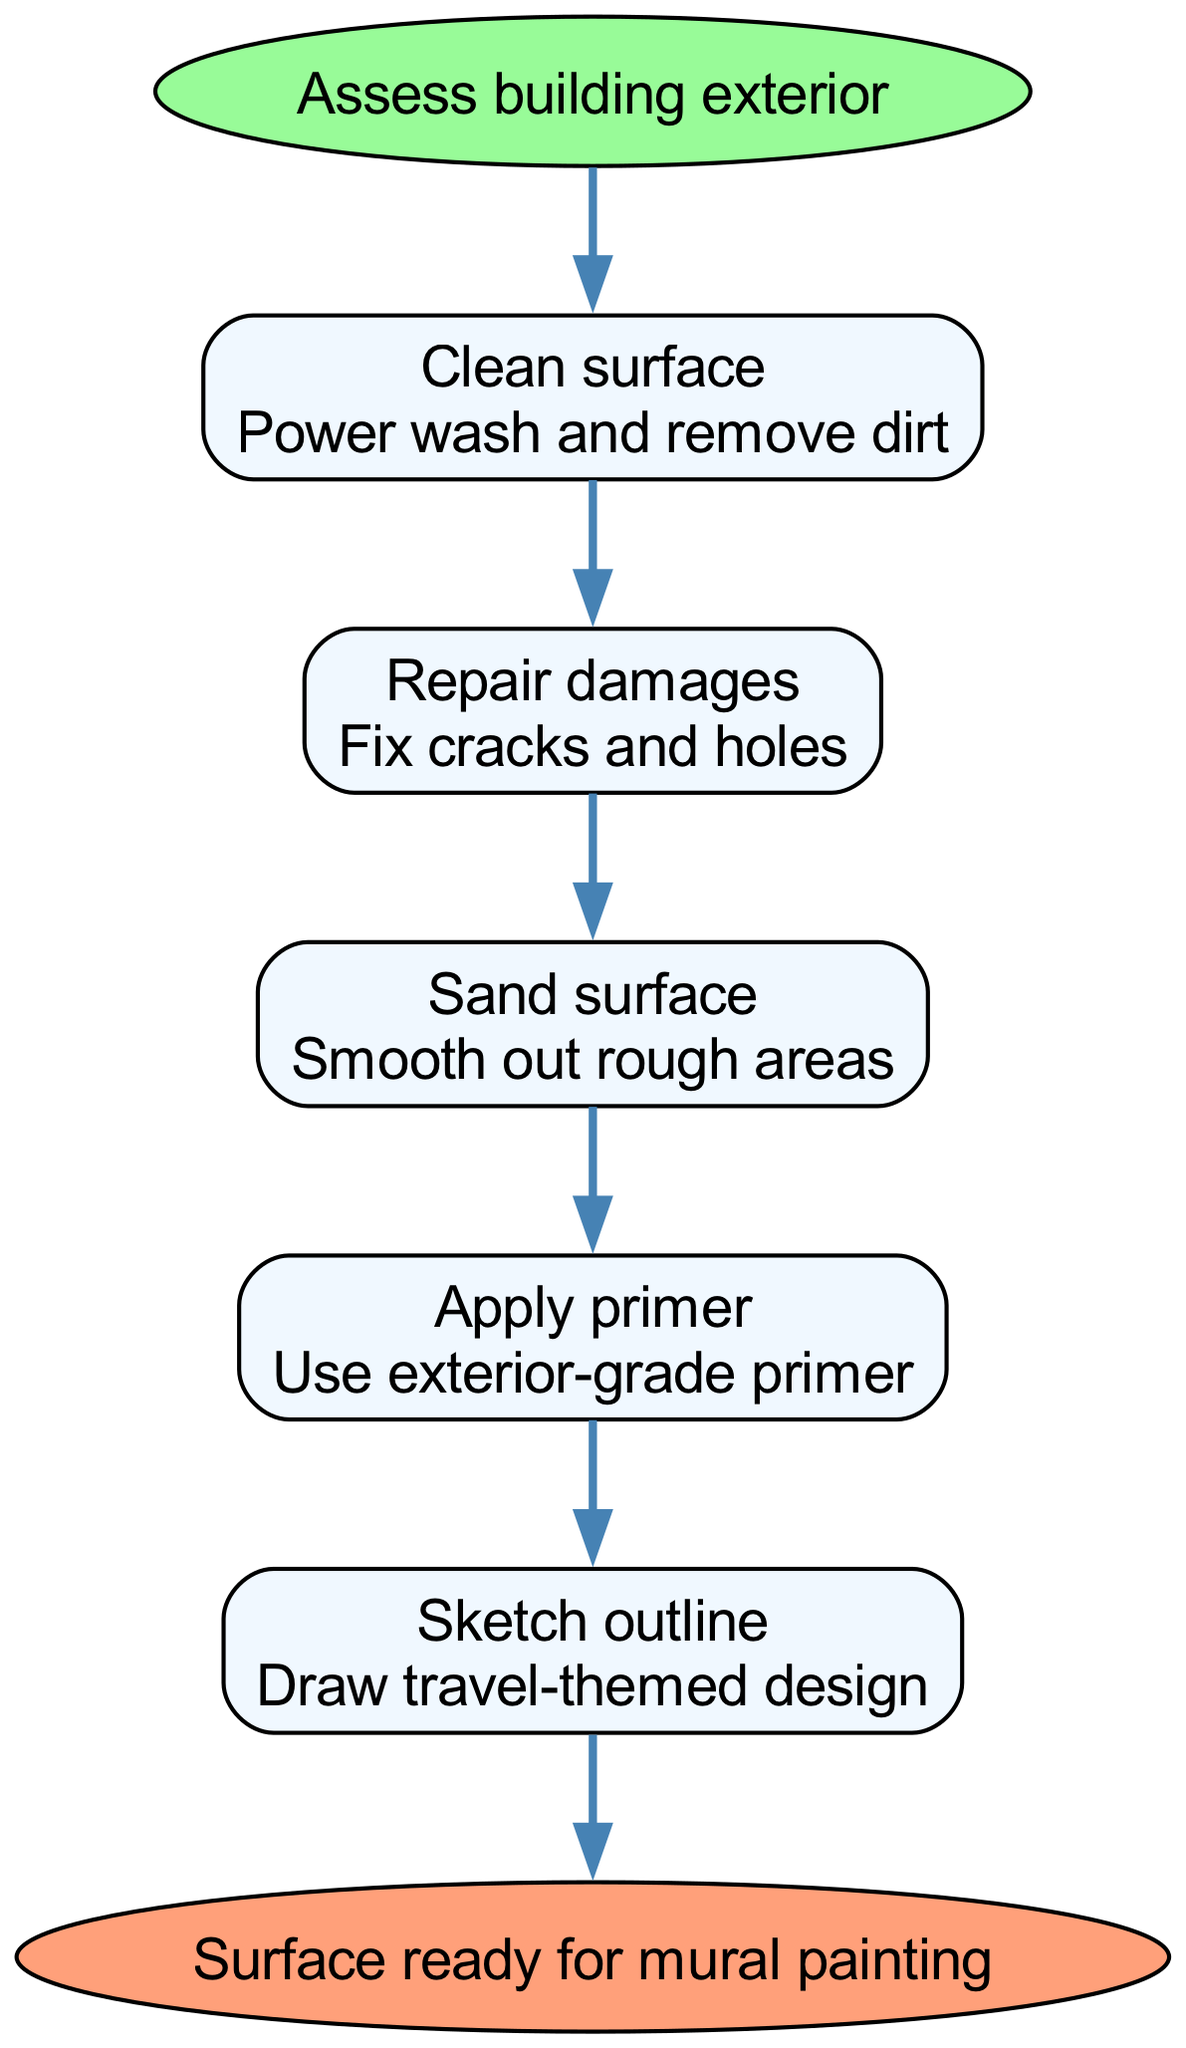What is the first step in preparing the surface? The diagram indicates that the first step is to "Assess building exterior," which is the starting point of the flow.
Answer: Assess building exterior How many steps are there in total? By counting each step in the flow chart after the start node, there are five individual steps listed before reaching the end.
Answer: 5 What is the last action before the surface is ready for mural painting? The final action indicated before reaching the end node in the flow chart is "Sketch outline," which suggests that the design is drawn just before completing surface preparation.
Answer: Sketch outline What is done to the surface during the third step? The third step in the diagram indicates to "Sand surface," which means that rough areas on the surface will be smoothed out.
Answer: Sand surface Which step involves applying a product, and what type is it? The fourth step states "Apply primer," specifying that an exterior-grade primer is used to prepare the surface for painting.
Answer: Apply primer How does the 'Repair damages' step relate to the 'Clean surface' step? The 'Repair damages' step follows the 'Clean surface' step, indicating that after cleaning the surface, any existing cracks and holes are then fixed as part of the preparation process.
Answer: Repair damages follows Clean surface What does the second step focus on? The second step, titled "Repair damages," focuses on fixing any cracks and holes found on the surface to ensure it is even and suitable for painting.
Answer: Fix cracks and holes What color represents the start node in the diagram? The start node is represented in a green color, which signifies the beginning of the process in this flow chart.
Answer: Green 